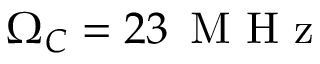Convert formula to latex. <formula><loc_0><loc_0><loc_500><loc_500>\Omega _ { C } = 2 3 \, M H z</formula> 